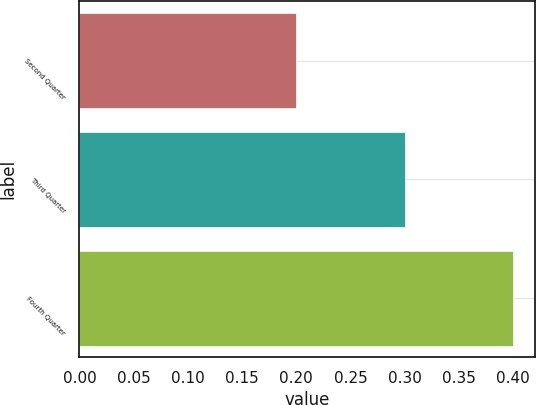Convert chart to OTSL. <chart><loc_0><loc_0><loc_500><loc_500><bar_chart><fcel>Second Quarter<fcel>Third Quarter<fcel>Fourth Quarter<nl><fcel>0.2<fcel>0.3<fcel>0.4<nl></chart> 